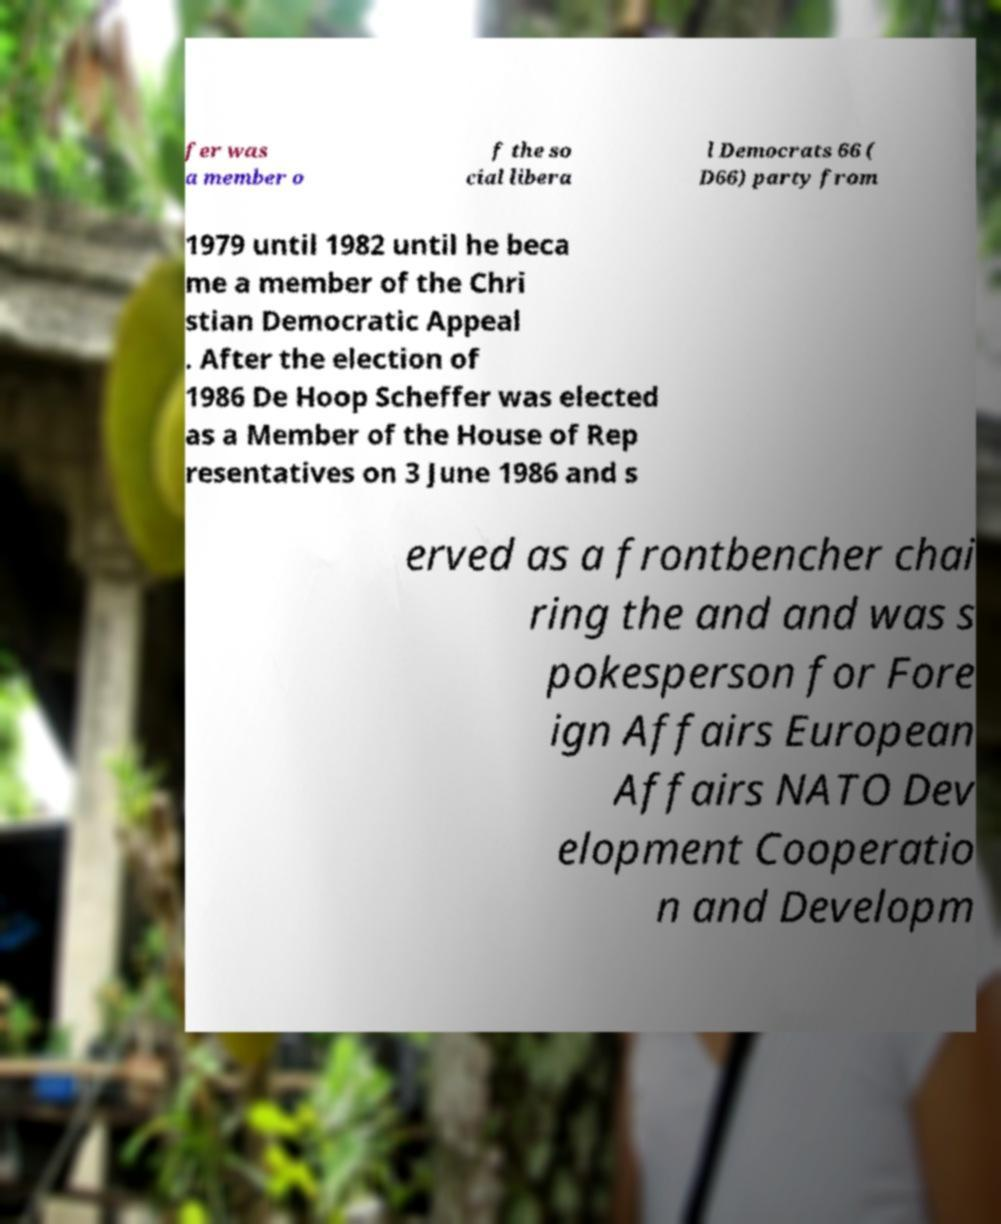Can you read and provide the text displayed in the image?This photo seems to have some interesting text. Can you extract and type it out for me? fer was a member o f the so cial libera l Democrats 66 ( D66) party from 1979 until 1982 until he beca me a member of the Chri stian Democratic Appeal . After the election of 1986 De Hoop Scheffer was elected as a Member of the House of Rep resentatives on 3 June 1986 and s erved as a frontbencher chai ring the and and was s pokesperson for Fore ign Affairs European Affairs NATO Dev elopment Cooperatio n and Developm 